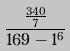<formula> <loc_0><loc_0><loc_500><loc_500>\frac { \frac { 3 4 0 } { 7 } } { 1 6 9 - 1 ^ { 6 } }</formula> 